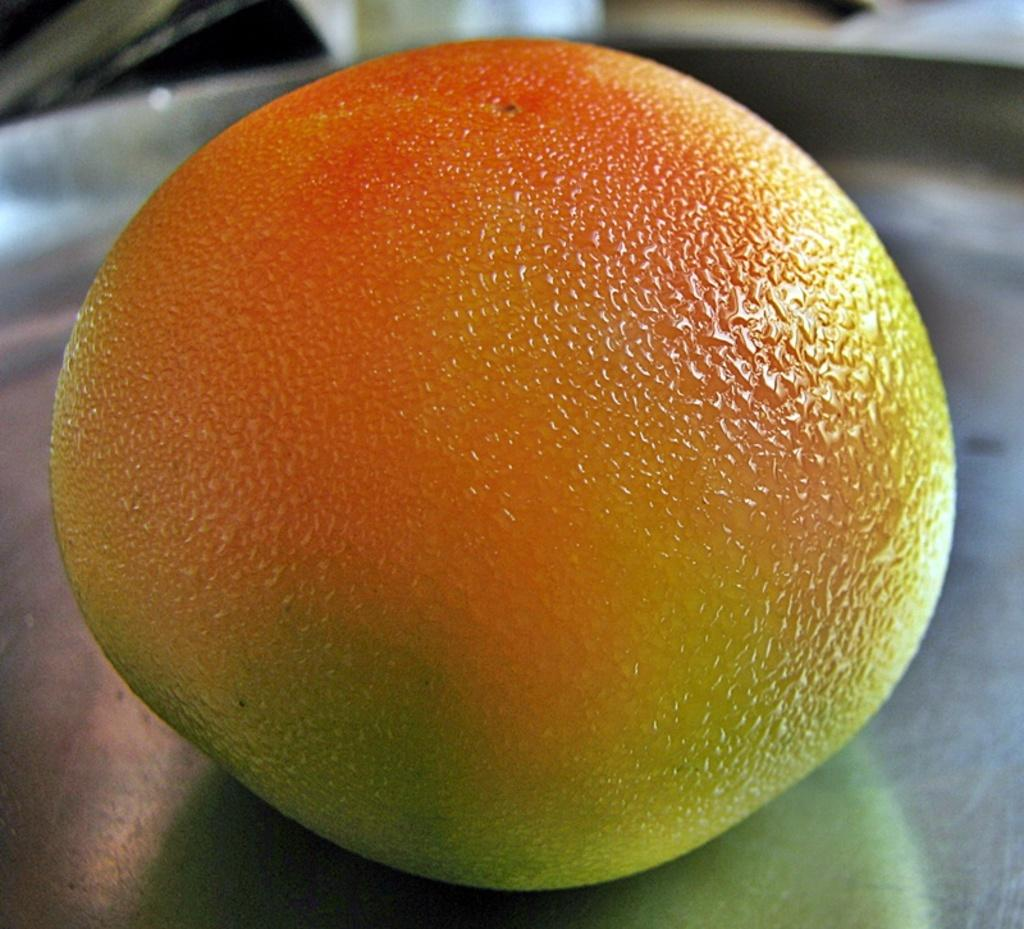What type of food is present in the image? There is a fruit in the image. What colors can be seen on the fruit? The fruit has yellow and orange colors. What is the fruit resting on in the image? The fruit is on a silver-colored object. What type of berry can be seen in the image? The image does not show a berry; it features a fruit with yellow and orange colors. Can you tell me how many bags of popcorn are visible in the image? There are no bags of popcorn present in the image. 